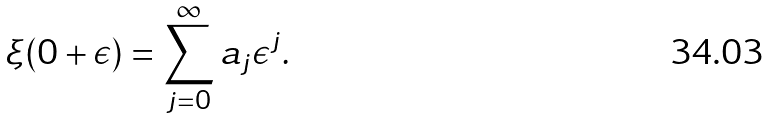Convert formula to latex. <formula><loc_0><loc_0><loc_500><loc_500>\xi ( 0 + \epsilon ) = \sum _ { j = 0 } ^ { \infty } a _ { j } \epsilon ^ { j } .</formula> 